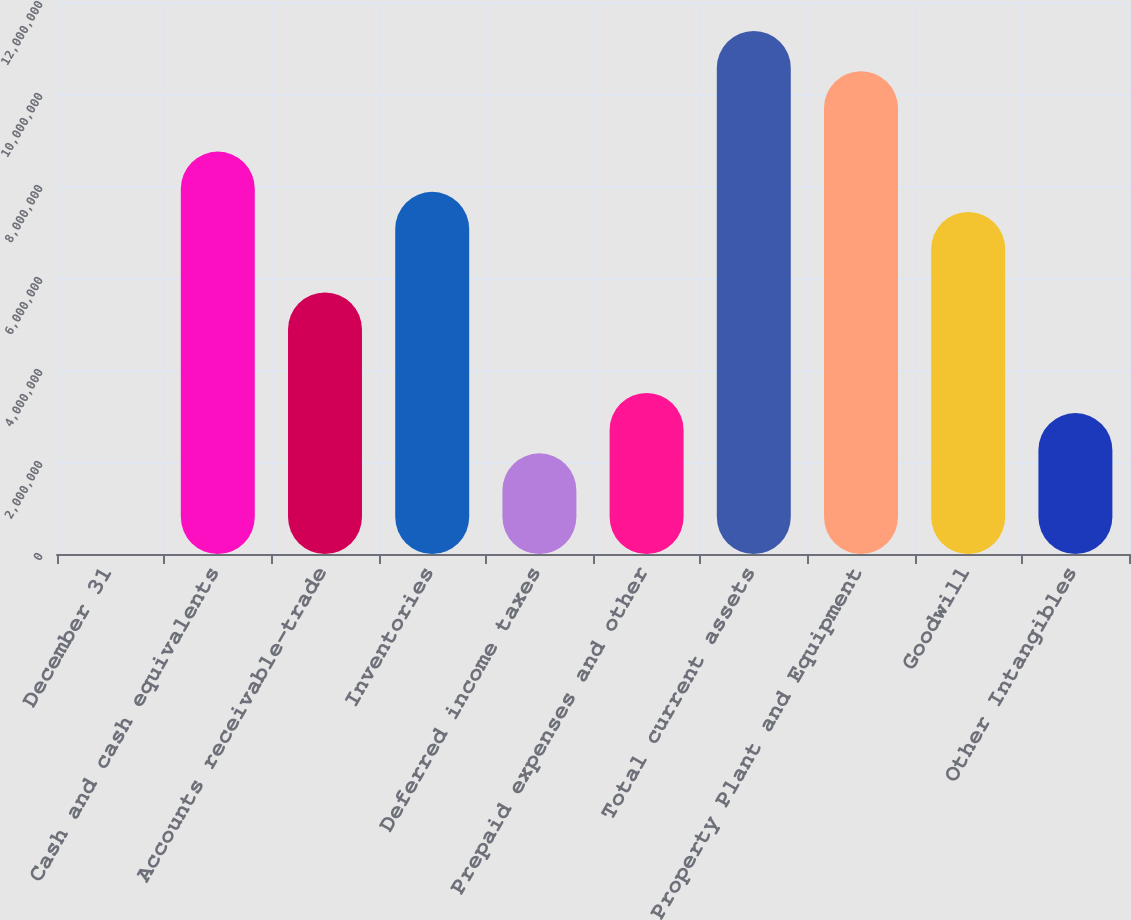Convert chart to OTSL. <chart><loc_0><loc_0><loc_500><loc_500><bar_chart><fcel>December 31<fcel>Cash and cash equivalents<fcel>Accounts receivable-trade<fcel>Inventories<fcel>Deferred income taxes<fcel>Prepaid expenses and other<fcel>Total current assets<fcel>Property Plant and Equipment<fcel>Goodwill<fcel>Other Intangibles<nl><fcel>2010<fcel>8.74743e+06<fcel>5.68653e+06<fcel>7.87288e+06<fcel>2.18836e+06<fcel>3.50018e+06<fcel>1.13711e+07<fcel>1.04965e+07<fcel>7.43561e+06<fcel>3.06291e+06<nl></chart> 